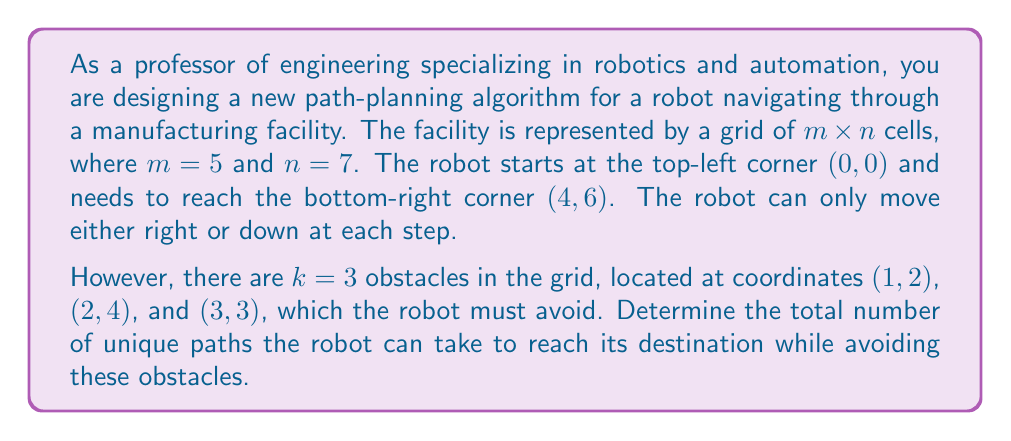Solve this math problem. To solve this problem, we'll use a combination of the lattice path counting technique and dynamic programming, considering the obstacles.

1) First, let's create a 5x7 grid to represent the facility:

[asy]
unitsize(1cm);
for(int i=0; i<=5; ++i) draw((0,i)--(7,i));
for(int j=0; j<=7; ++j) draw((j,0)--(j,5));
label("S", (0,5), NW);
label("E", (7,0), SE);
fill((2,3)--cycle,gray);
fill((4,2)--cycle,gray);
fill((3,1)--cycle,gray);
[/asy]

2) We'll use dynamic programming to count the paths. Let $dp[i][j]$ represent the number of unique paths to reach cell $(i,j)$.

3) Initialize the first row and column of the dp array:
   - Set $dp[0][j] = 1$ for all $j$ until we hit an obstacle
   - Set $dp[i][0] = 1$ for all $i$ until we hit an obstacle

4) For the rest of the cells, we use the recurrence relation:
   $dp[i][j] = dp[i-1][j] + dp[i][j-1]$ if the cell is not an obstacle
   $dp[i][j] = 0$ if the cell is an obstacle

5) The recurrence relation works because to reach any cell, the robot can come either from above or from the left.

6) After filling the dp array, the value in $dp[4][6]$ will give us the total number of unique paths.

Here's how the dp array would look like (only showing the relevant part):

$$
\begin{array}{c|ccccccc}
  & 0 & 1 & 2 & 3 & 4 & 5 & 6 \\
\hline
0 & 1 & 1 & 1 & 1 & 1 & 1 & 1 \\
1 & 1 & 2 & 0 & 1 & 1 & 2 & 3 \\
2 & 1 & 3 & 3 & 4 & 0 & 2 & 5 \\
3 & 1 & 4 & 7 & 0 & 4 & 6 & 11 \\
4 & 1 & 5 & 12 & 12 & 16 & 22 & 33 \\
\end{array}
$$

Therefore, the total number of unique paths avoiding the obstacles is 33.
Answer: 33 unique paths 